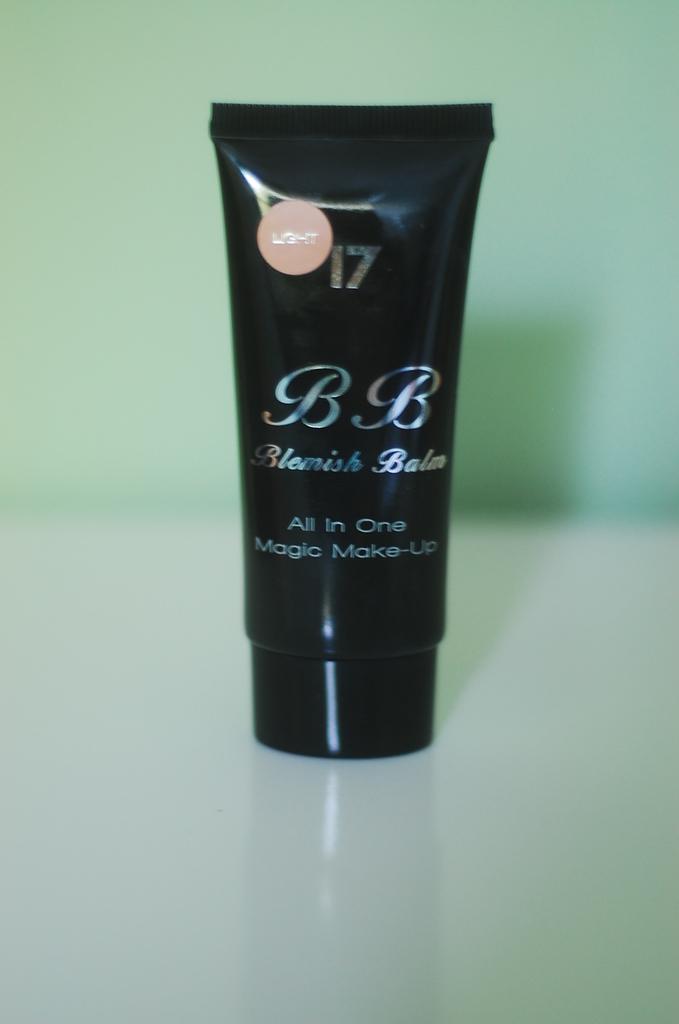What is this brand of cream called?
Offer a very short reply. Blemish balm. What is the number?
Your response must be concise. 17. 